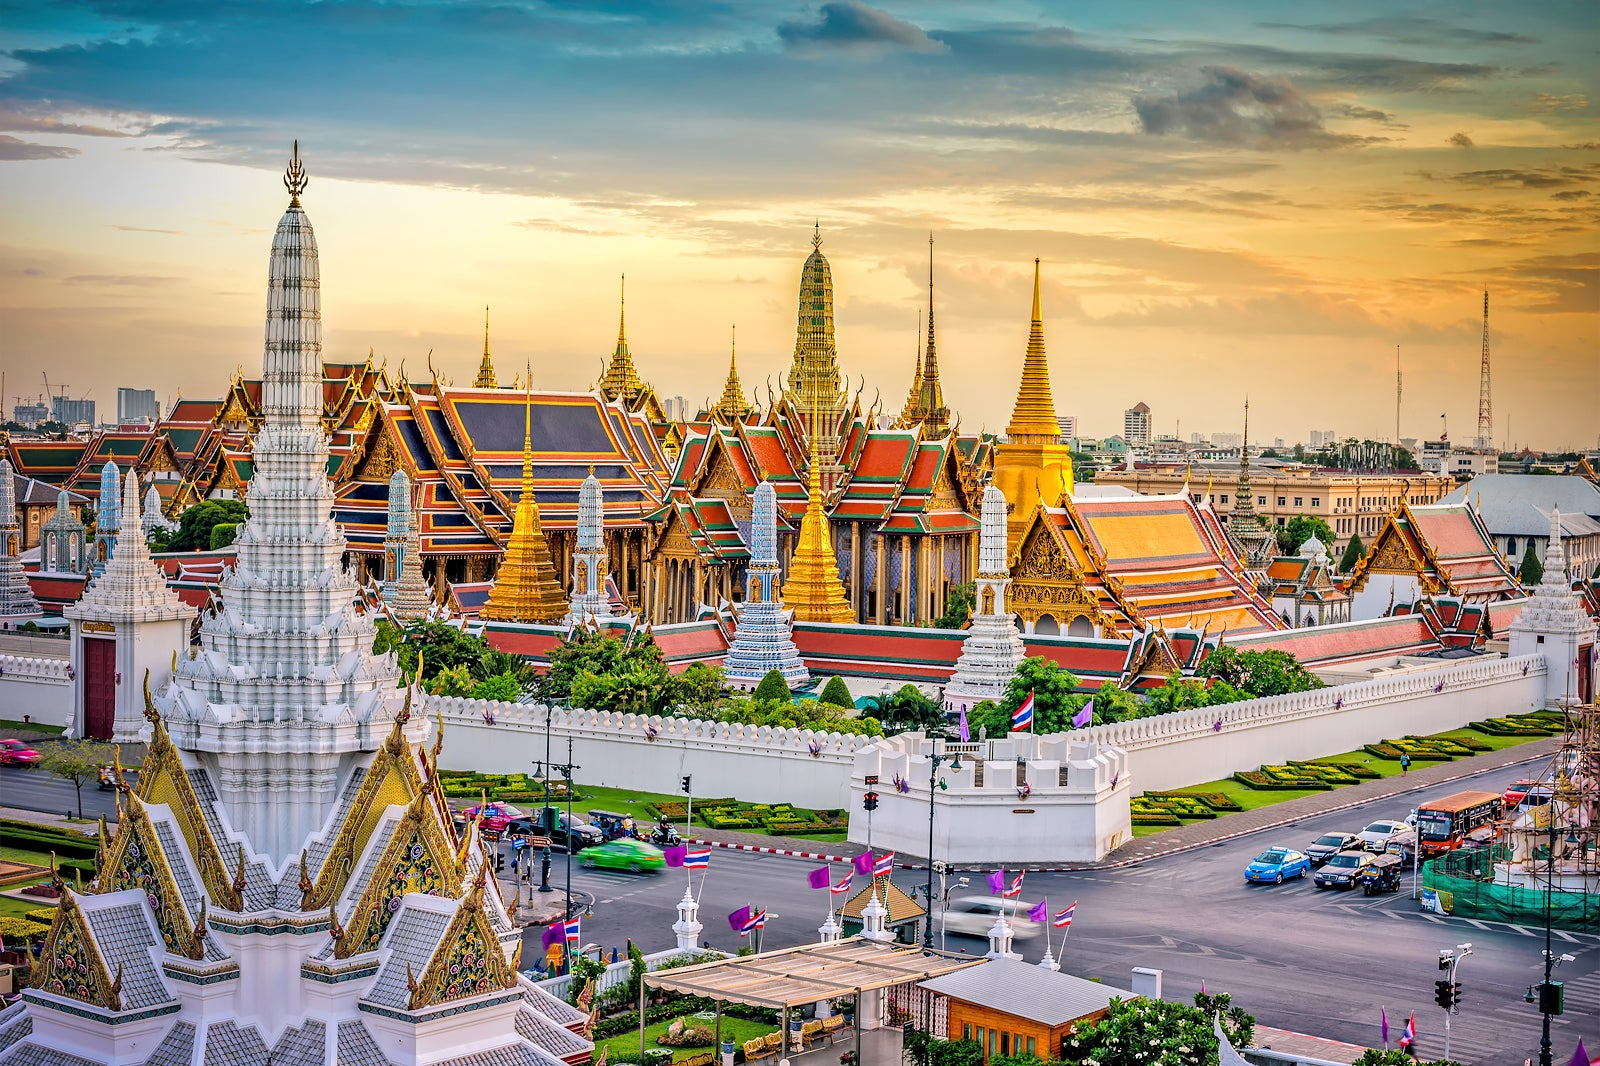Imagine the palace comes to life and can speak. What stories would it tell? If the Grand Palace could speak, it would recount tales of royal grandeur, political intrigue, and cultural evolution. It might share stories of the early days of its construction under King Rama I, the bustling activities of court life, and the solemnity of royal ceremonies. It would describe the opulence of royal banquets, the whispers of secret negotiations in its chambers, and the echo of laughter and cries during festive occasions and national crises. The palace would tell of the changes it has seen - from the era of absolute monarchy to the present day, showcasing its role as a symbol of continuity and resilience in Thai society. 